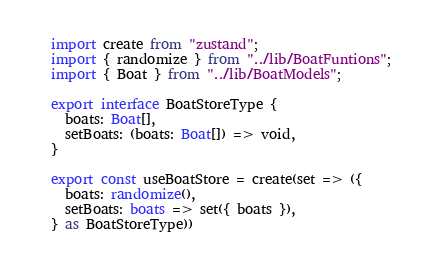Convert code to text. <code><loc_0><loc_0><loc_500><loc_500><_TypeScript_>import create from "zustand";
import { randomize } from "../lib/BoatFuntions";
import { Boat } from "../lib/BoatModels";

export interface BoatStoreType {
  boats: Boat[],
  setBoats: (boats: Boat[]) => void,
}

export const useBoatStore = create(set => ({
  boats: randomize(),
  setBoats: boats => set({ boats }),
} as BoatStoreType))</code> 